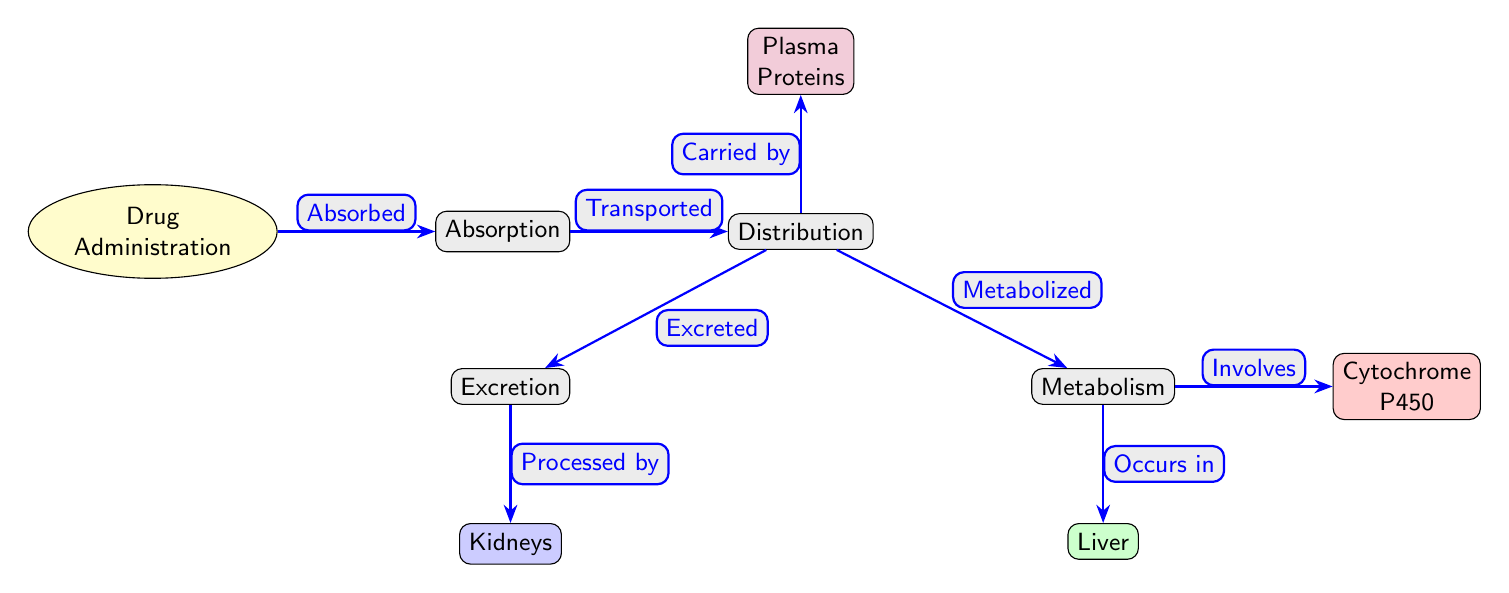What is the first step in the diagram? The diagram starts with the "Drug Administration" node, which is the initial action in the pharmacokinetic process displayed.
Answer: Drug Administration How many nodes are present in the diagram? Counting all the distinct points represented in the diagram, there are nine nodes, including all processes and locations.
Answer: 9 What occurs after absorption? The diagram indicates that once a drug is absorbed, it is "Transported" to the next process, which is "Distribution."
Answer: Transported Which organ is specifically labeled for metabolism? The "Liver" node is distinctly labeled for the metabolism of drugs, indicating where this process occurs.
Answer: Liver What is the relationship between distribution and excretion? The diagram shows a direct arrow from "Distribution" to "Excretion," indicating that distribution leads to the process of drug excretion.
Answer: Excretion Which proteins carry the drug in the plasma? The "Plasma Proteins" node is present, showing that they are involved in the transportation of drugs within the bloodstream.
Answer: Plasma Proteins What role does cytochrome P450 play in the diagram? The "Cytochrome P450" node indicates that it is involved in the metabolism of drugs, as shown by the arrow connecting the metabolism to this node.
Answer: Involves How are kidneys related to drug metabolism? The "Kidneys" node is connected to "Excretion," demonstrating that they process the drugs after their distribution and metabolism.
Answer: Processed by What is transported after drug administration according to the diagram? After "Drug Administration," the diagram shows that the drug is absorbed and subsequently transported to the "Distribution" process.
Answer: Distributed 